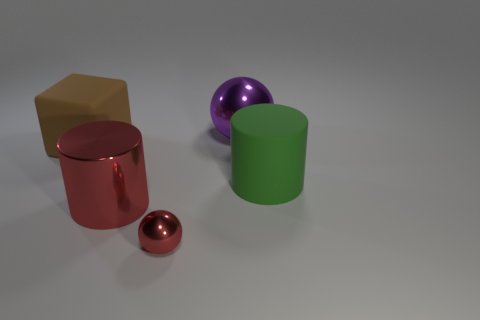Does the purple metal thing have the same shape as the large red thing?
Your answer should be very brief. No. There is a thing to the left of the large metallic thing that is in front of the big cylinder that is behind the red cylinder; what size is it?
Provide a short and direct response. Large. How many other objects are there of the same material as the red cylinder?
Your response must be concise. 2. There is a cylinder that is left of the tiny red metal thing; what is its color?
Your response must be concise. Red. What is the material of the cylinder that is behind the big metal thing in front of the rubber object that is on the right side of the brown thing?
Give a very brief answer. Rubber. Are there any big green rubber objects that have the same shape as the brown thing?
Make the answer very short. No. The matte thing that is the same size as the block is what shape?
Make the answer very short. Cylinder. How many big objects are both in front of the brown matte cube and to the right of the small red metal object?
Keep it short and to the point. 1. Is the number of big objects that are behind the matte cube less than the number of large matte objects?
Give a very brief answer. Yes. Are there any brown things of the same size as the red cylinder?
Offer a very short reply. Yes. 